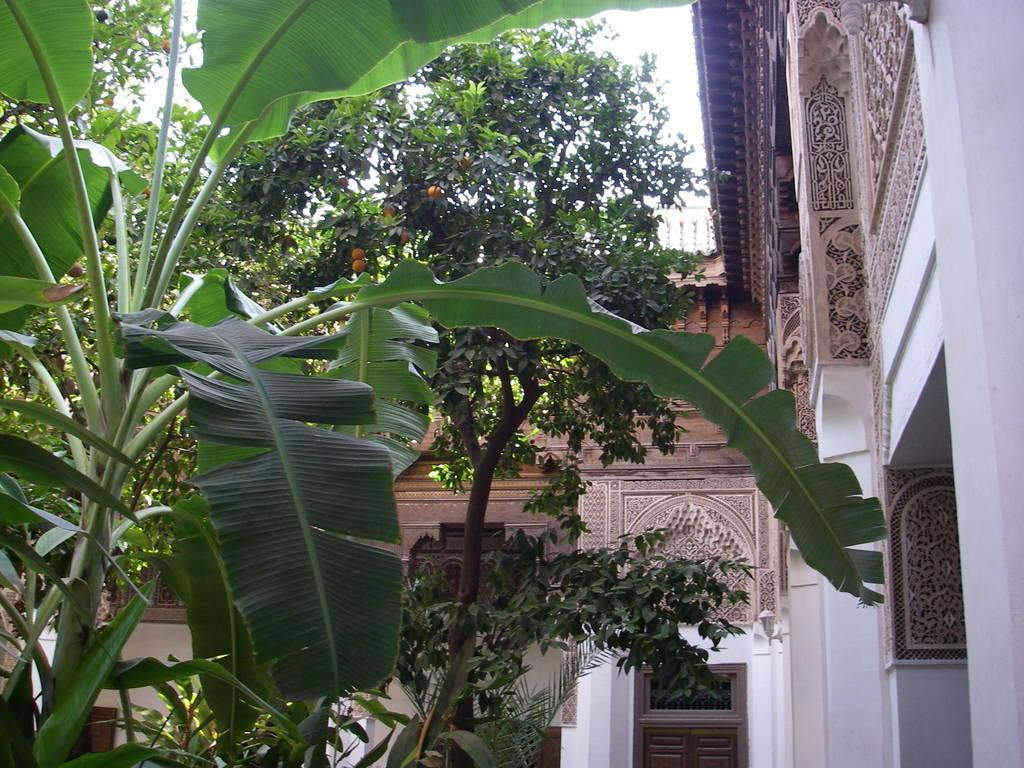What type of plant is located on the left side of the image? There is a banana plant on the left side of the image. What type of plant is in the middle of the image? There is an orange plant in the middle of the image. What fruit can be seen on the orange plant? There are oranges on the orange plant. What structure is located on the right side of the image? There is a monument on the right side of the image. Where can the blood-red boats be seen in the image? There are no blood-red boats present in the image. 